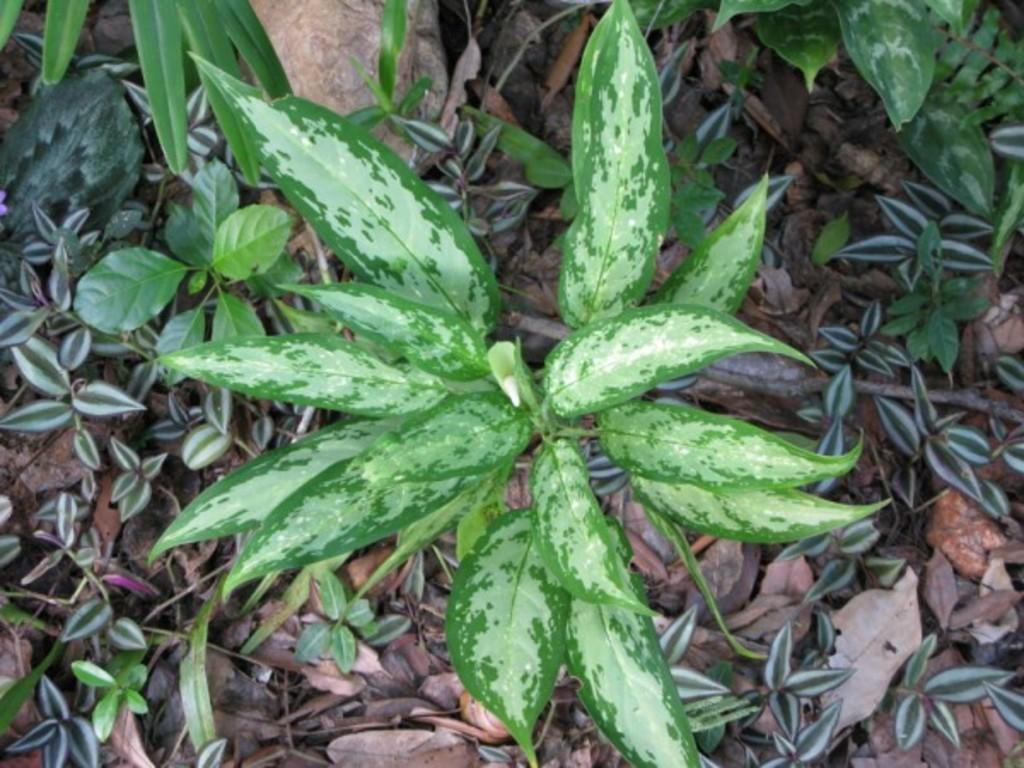What is the main subject in the middle of the image? There is a plant with green leaves in the middle of the image. What can be seen at the bottom of the image? There are dry leaves and small plants at the bottom of the image. What is located at the top of the image? There is a stone at the top of the image. What park is visible in the background of the image? There is no park visible in the image; it only features a plant, dry leaves, small plants, and a stone. What are the hands of the person holding in the image? There are no hands or person present in the image. 